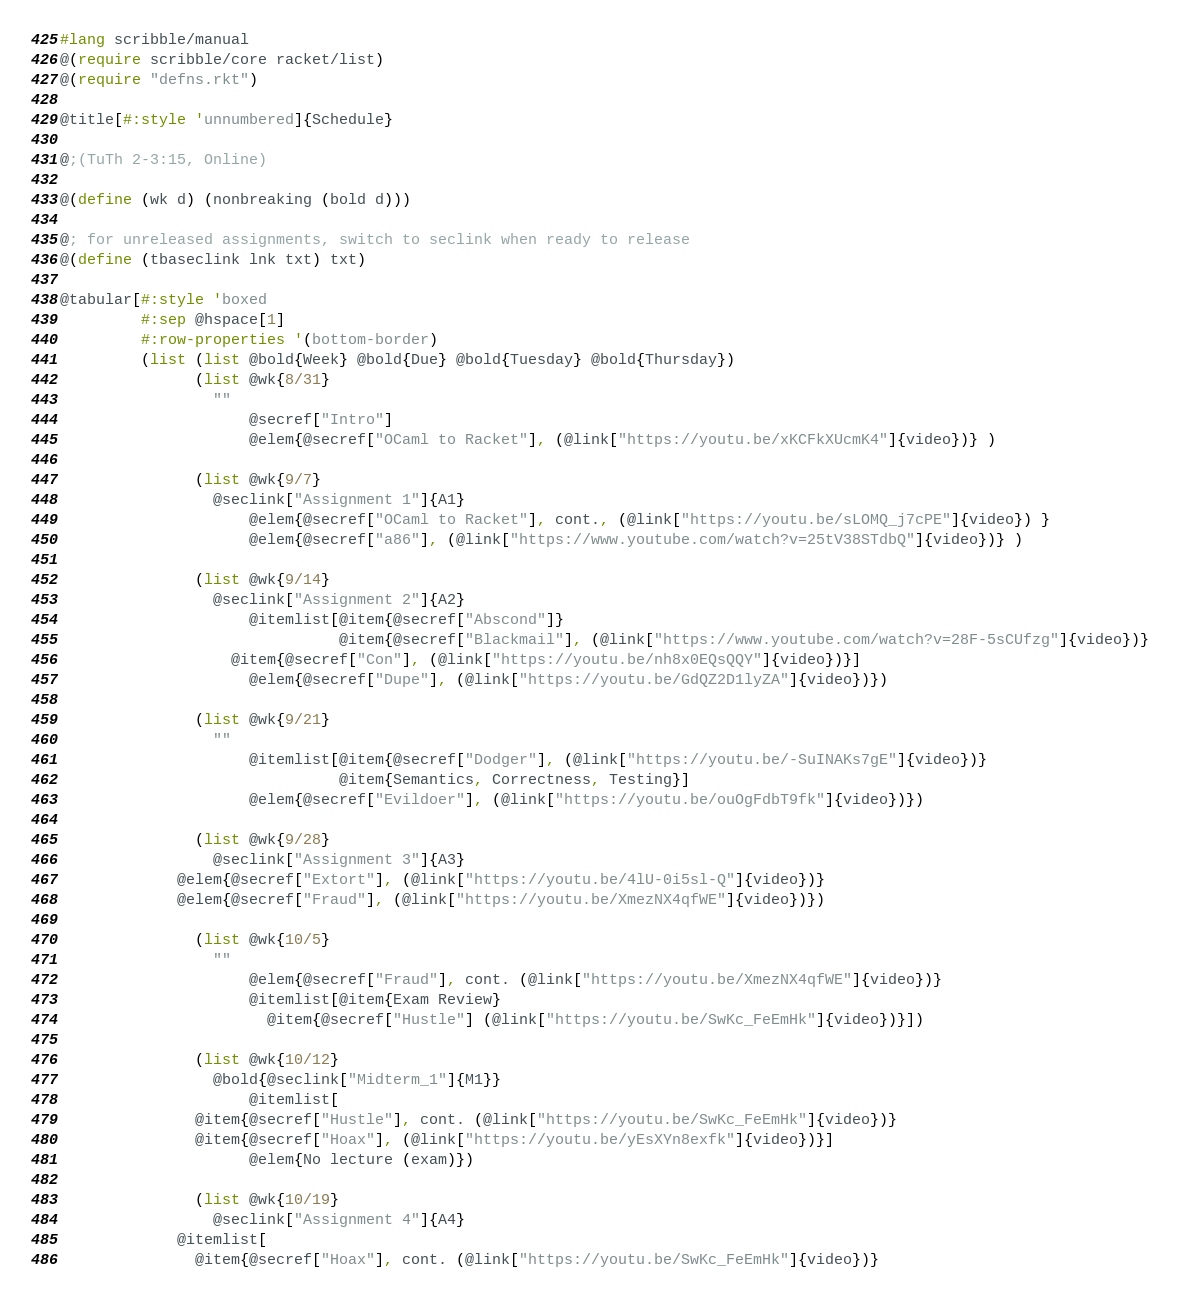Convert code to text. <code><loc_0><loc_0><loc_500><loc_500><_Racket_>#lang scribble/manual
@(require scribble/core racket/list)
@(require "defns.rkt")

@title[#:style 'unnumbered]{Schedule}

@;(TuTh 2-3:15, Online)

@(define (wk d) (nonbreaking (bold d)))

@; for unreleased assignments, switch to seclink when ready to release
@(define (tbaseclink lnk txt) txt)

@tabular[#:style 'boxed
         #:sep @hspace[1] 
         #:row-properties '(bottom-border)
         (list (list @bold{Week} @bold{Due} @bold{Tuesday} @bold{Thursday})
               (list @wk{8/31}
	       	     ""
                     @secref["Intro"]
                     @elem{@secref["OCaml to Racket"], (@link["https://youtu.be/xKCFkXUcmK4"]{video})} )

               (list @wk{9/7}
	       	     @seclink["Assignment 1"]{A1}
                     @elem{@secref["OCaml to Racket"], cont., (@link["https://youtu.be/sLOMQ_j7cPE"]{video}) }
                     @elem{@secref["a86"], (@link["https://www.youtube.com/watch?v=25tV38STdbQ"]{video})} )

               (list @wk{9/14}
	       	     @seclink["Assignment 2"]{A2}
                     @itemlist[@item{@secref["Abscond"]}
                               @item{@secref["Blackmail"], (@link["https://www.youtube.com/watch?v=28F-5sCUfzg"]{video})}
			       @item{@secref["Con"], (@link["https://youtu.be/nh8x0EQsQQY"]{video})}]
                     @elem{@secref["Dupe"], (@link["https://youtu.be/GdQZ2D1lyZA"]{video})})

               (list @wk{9/21}
	             ""
                     @itemlist[@item{@secref["Dodger"], (@link["https://youtu.be/-SuINAKs7gE"]{video})}
                               @item{Semantics, Correctness, Testing}]
                     @elem{@secref["Evildoer"], (@link["https://youtu.be/ouOgFdbT9fk"]{video})})
                                    
               (list @wk{9/28}
	       	     @seclink["Assignment 3"]{A3}
		     @elem{@secref["Extort"], (@link["https://youtu.be/4lU-0i5sl-Q"]{video})}
		     @elem{@secref["Fraud"], (@link["https://youtu.be/XmezNX4qfWE"]{video})})
               
               (list @wk{10/5}
	       	     ""
                     @elem{@secref["Fraud"], cont. (@link["https://youtu.be/XmezNX4qfWE"]{video})}
                     @itemlist[@item{Exam Review}
		               @item{@secref["Hustle"] (@link["https://youtu.be/SwKc_FeEmHk"]{video})}])
               
               (list @wk{10/12}
	       	     @bold{@seclink["Midterm_1"]{M1}}
                     @itemlist[
		       @item{@secref["Hustle"], cont. (@link["https://youtu.be/SwKc_FeEmHk"]{video})}
		       @item{@secref["Hoax"], (@link["https://youtu.be/yEsXYn8exfk"]{video})}]
                     @elem{No lecture (exam)})

               (list @wk{10/19}                     
	       	     @seclink["Assignment 4"]{A4}
		     @itemlist[
		       @item{@secref["Hoax"], cont. (@link["https://youtu.be/SwKc_FeEmHk"]{video})}</code> 